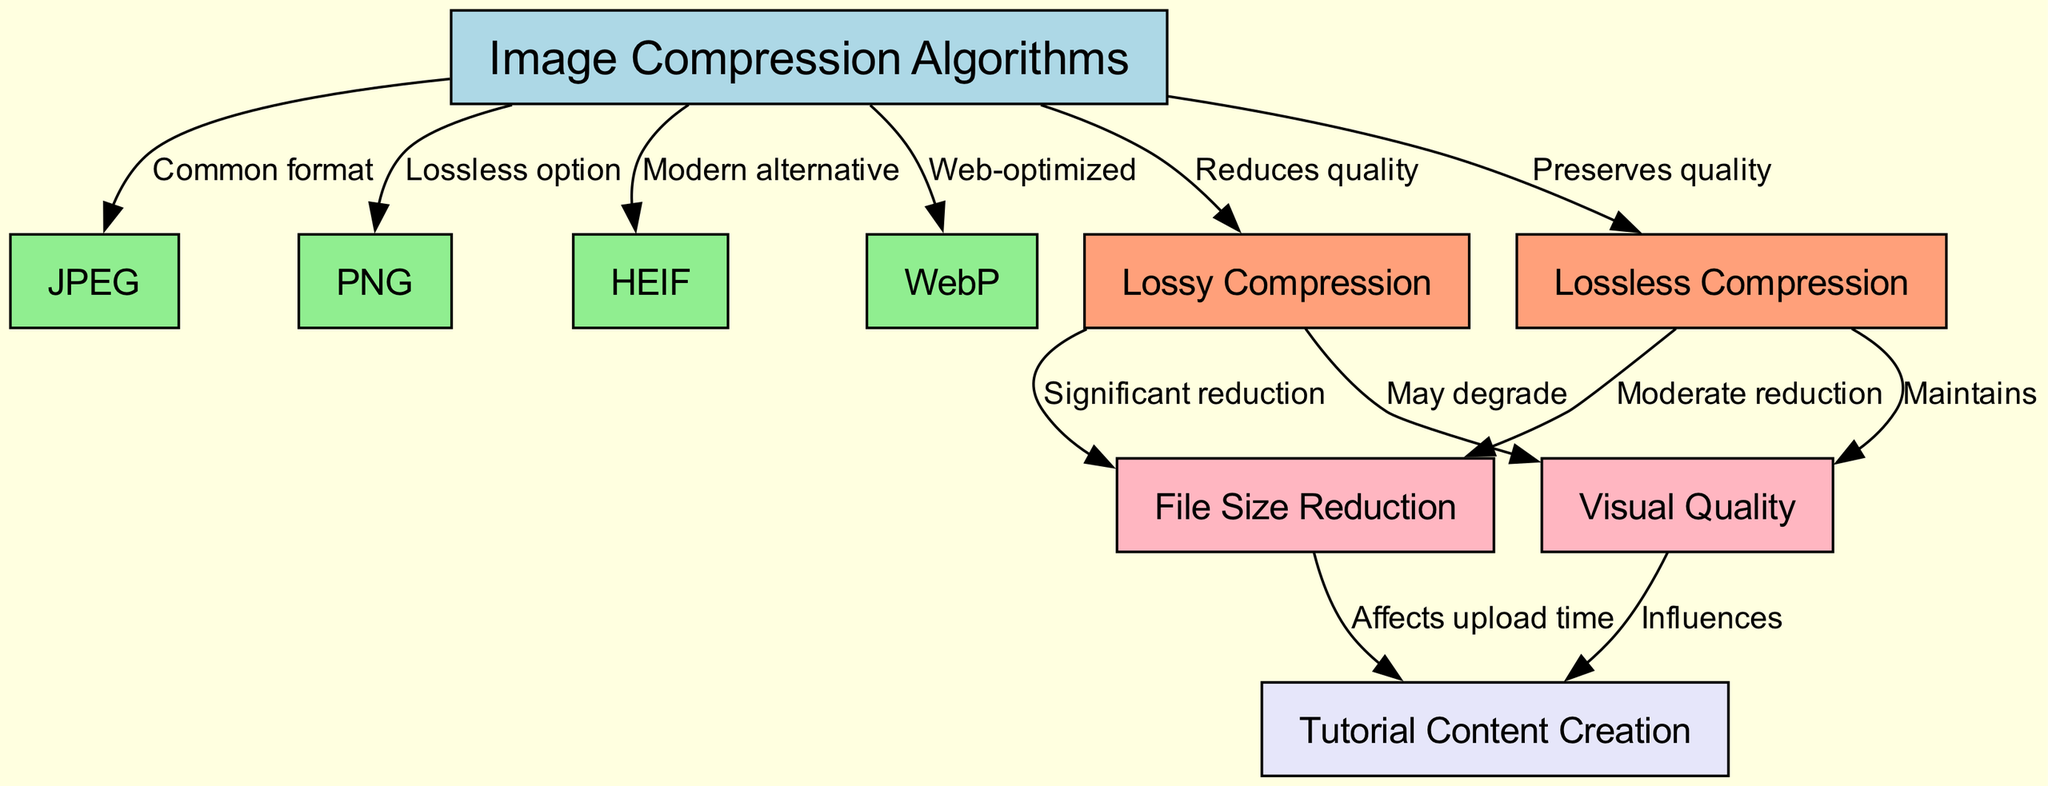What are the four types of image compression algorithms mentioned? The diagram lists JPEG, PNG, HEIF, and WebP as the four types of image compression algorithms.
Answer: JPEG, PNG, HEIF, WebP How many nodes are dedicated to compression types? By reviewing the nodes, we see that there are a total of four nodes focusing on compression types: JPEG, PNG, HEIF, and WebP.
Answer: Four What is the relationship between lossy compression and file size reduction? The diagram indicates that lossy compression can lead to significant file size reduction, establishing a direct relationship between them.
Answer: Significant reduction What type of compression preserves quality? The diagram clearly states that lossless compression is the type that preserves quality amidst the compression process.
Answer: Lossless Compression What does visual quality maintain in relation to lossless compression? According to the diagram, the visual quality aspect is maintained under lossless compression, meaning it does not degrade the image quality.
Answer: Maintains Is JPEG a modern alternative to image compression? Upon examining the connections, it becomes clear that JPEG is categorized under common formats, not a modern alternative, which is reserved for HEIF according to the diagram.
Answer: No Which compression type influences tutorial content creation? The diagram reveals that visual quality influences tutorial content creation, establishing a link between the two.
Answer: Visual Quality How does lossy compression affect image quality? The diagram illustrates that lossy compression may degrade image quality, indicating a potential downside in its application.
Answer: May degrade What color represents lossless compression in the diagram? The diagram indicates that lossless compression is represented in lightsalmon, which is the designated color for nodes related to this compression type.
Answer: Lightsalmon 